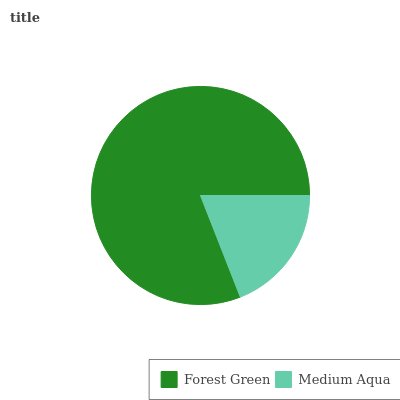Is Medium Aqua the minimum?
Answer yes or no. Yes. Is Forest Green the maximum?
Answer yes or no. Yes. Is Medium Aqua the maximum?
Answer yes or no. No. Is Forest Green greater than Medium Aqua?
Answer yes or no. Yes. Is Medium Aqua less than Forest Green?
Answer yes or no. Yes. Is Medium Aqua greater than Forest Green?
Answer yes or no. No. Is Forest Green less than Medium Aqua?
Answer yes or no. No. Is Forest Green the high median?
Answer yes or no. Yes. Is Medium Aqua the low median?
Answer yes or no. Yes. Is Medium Aqua the high median?
Answer yes or no. No. Is Forest Green the low median?
Answer yes or no. No. 